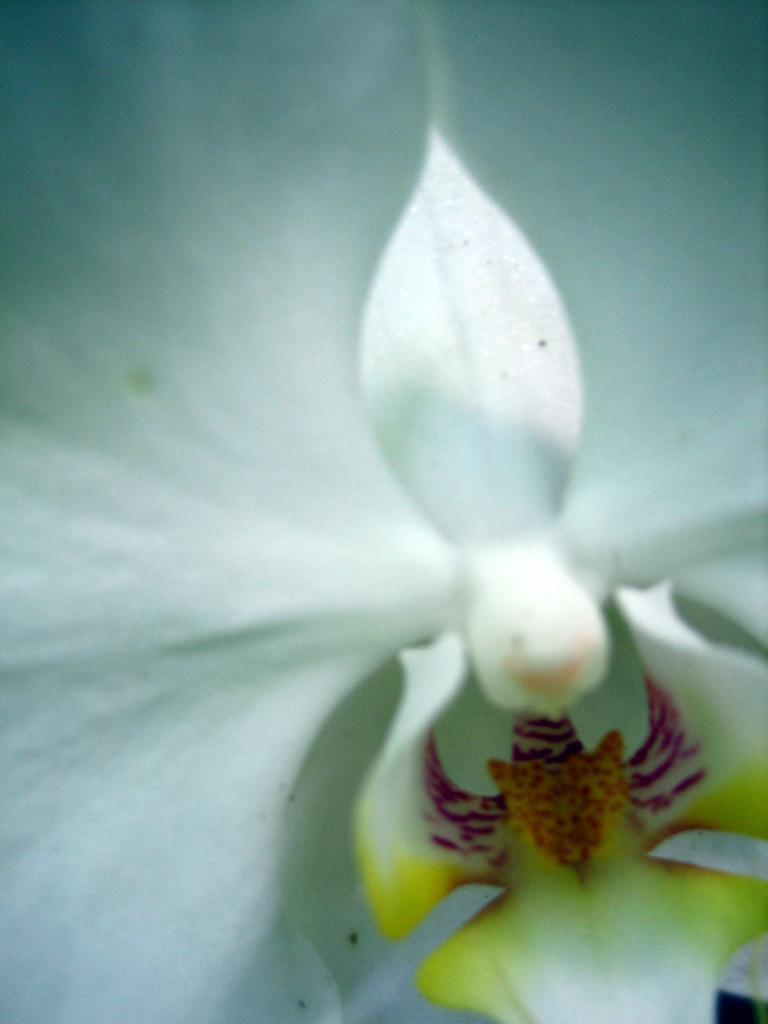What type of flower is present in the image? There is a white flower in the image. Can you see a hose being used to water the flower in the image? There is no hose visible in the image, and the flower does not appear to be receiving any water. Is there a rifle present in the image? No, there is no rifle present in the image. What type of beverage is being served alongside the flower in the image? There is no beverage present in the image; it only features a white flower. 